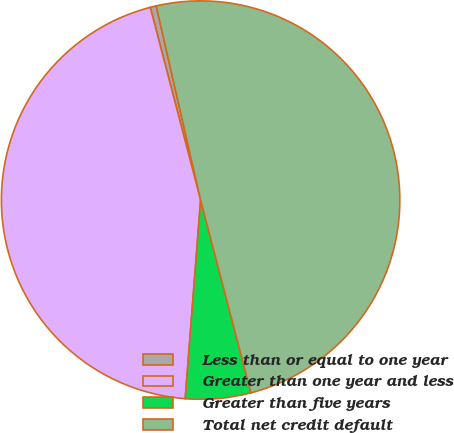<chart> <loc_0><loc_0><loc_500><loc_500><pie_chart><fcel>Less than or equal to one year<fcel>Greater than one year and less<fcel>Greater than five years<fcel>Total net credit default<nl><fcel>0.49%<fcel>44.7%<fcel>5.3%<fcel>49.51%<nl></chart> 